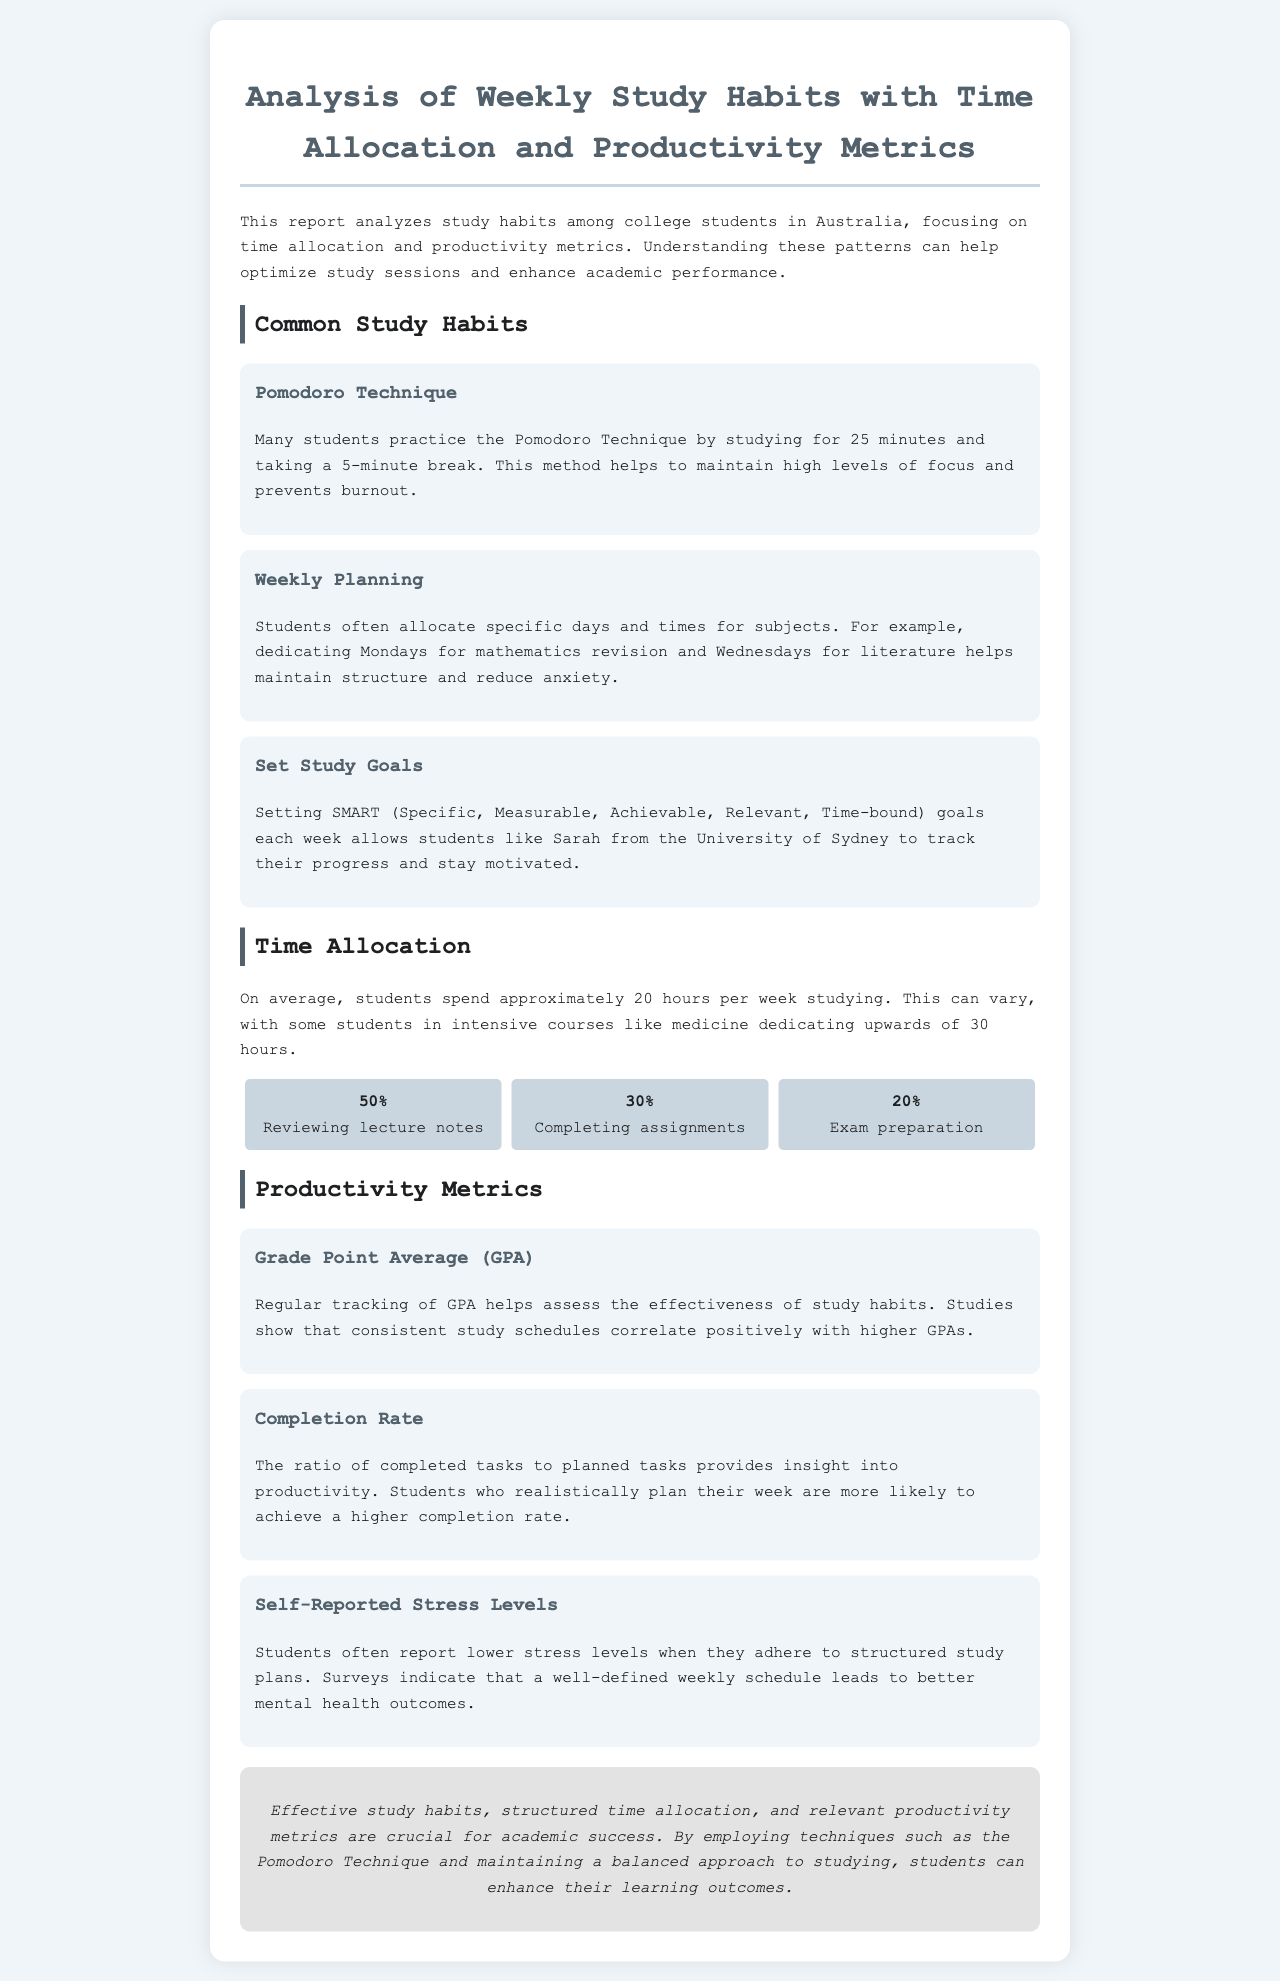what study technique involves studying for 25 minutes followed by a 5-minute break? This technique, mentioned in the document, is designed to help maintain focus and prevent burnout.
Answer: Pomodoro Technique what is the average number of hours students spend studying per week? The document provides a specific average based on student habits and studies.
Answer: 20 hours which percentage of study time is spent on reviewing lecture notes? The report specifies the allocation of time among different study activities, one of which is reviewing lecture notes.
Answer: 50% what is the focus of setting SMART goals in study habits? The document emphasizes tracking progress and staying motivated, which are key aspects of setting specific and measurable goals.
Answer: Tracking progress what correlation is mentioned between consistent study schedules and academic performance? The document outlines how adherence to certain study habits can influence academic outcomes positively.
Answer: Higher GPAs what percentage of study time is allocated for exam preparation? The report includes specific percentages of time dedicated to different aspects of study, including exam preparation.
Answer: 20% which method do students often use to structure their week for study? The document references a common practice used by students to reduce anxiety through organized planning.
Answer: Weekly Planning what does a higher completion rate indicate about students' productivity? The document explains that this ratio provides insight into the effectiveness of their planning.
Answer: Higher productivity what is the conclusion drawn about study habits and academic success? The conclusion summarizes the essential relationship between effective study habits and overall learning outcomes.
Answer: Crucial for academic success 